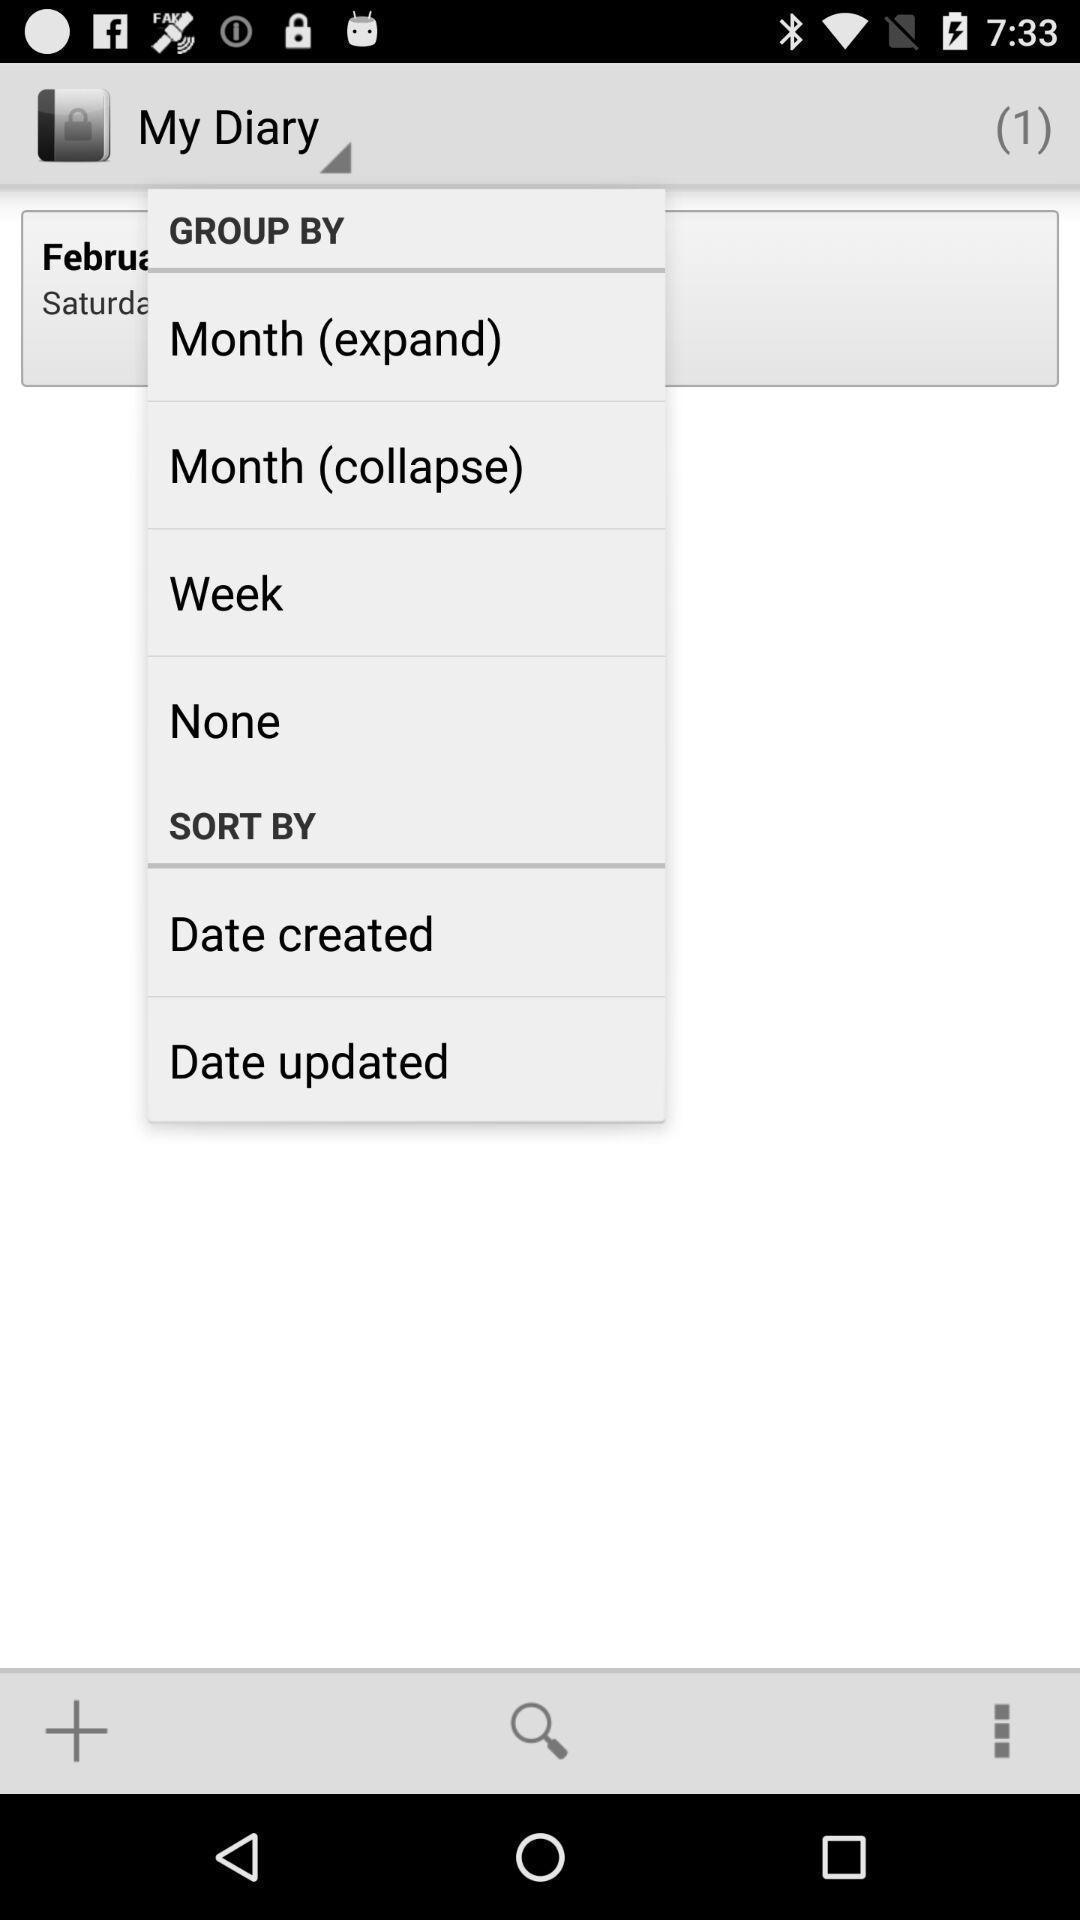Provide a detailed account of this screenshot. Pop up displaying the multiple options. 